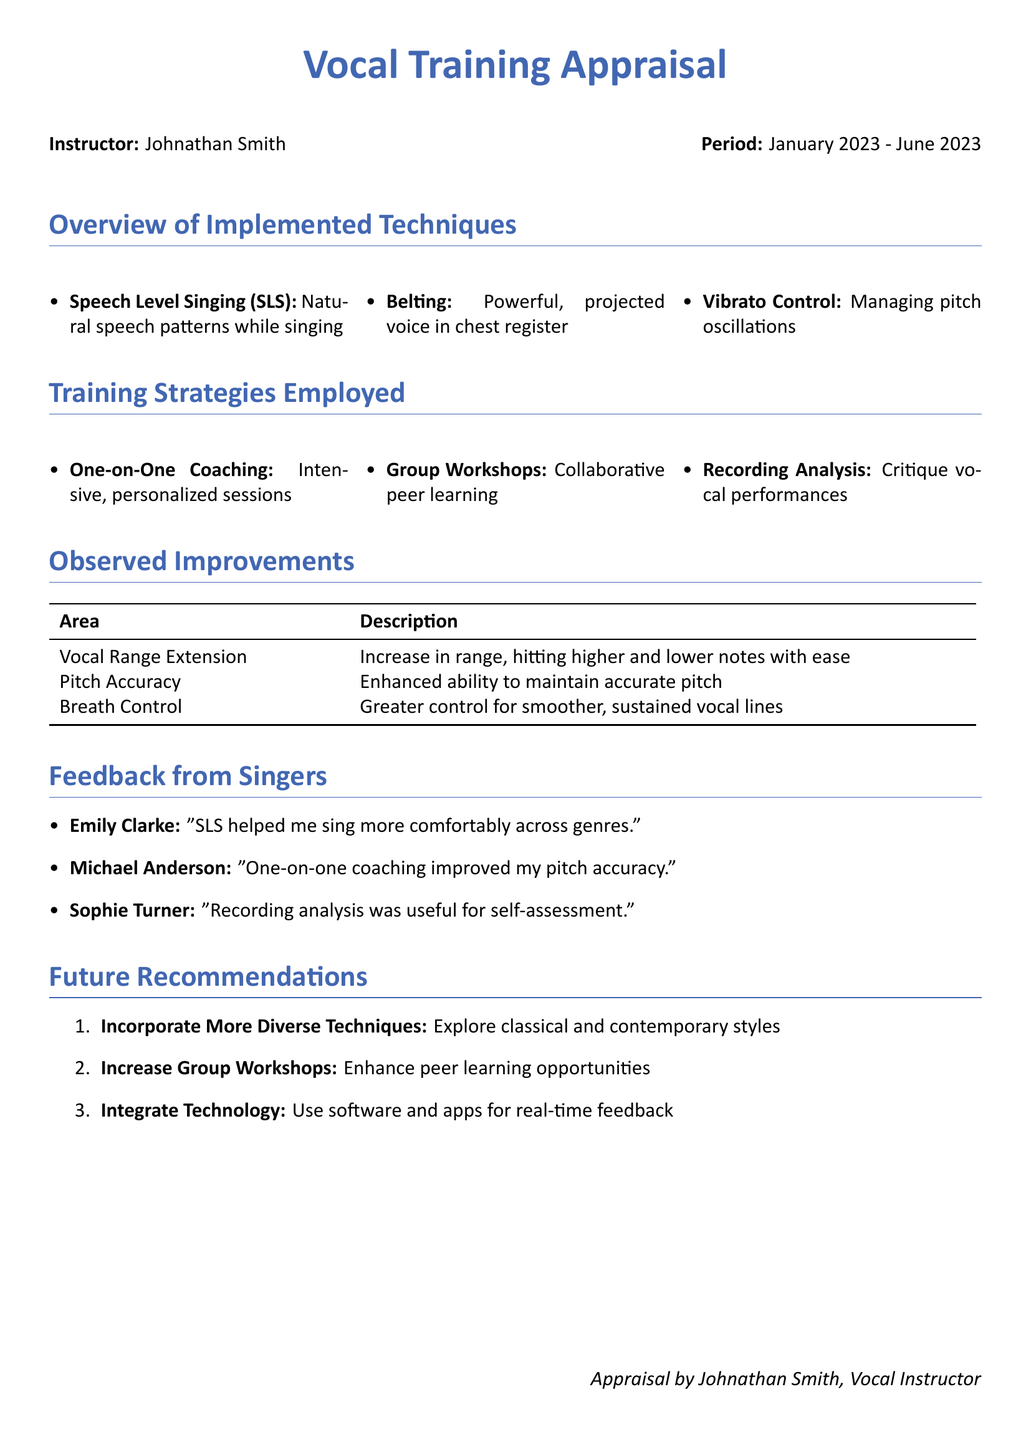What are the three vocal techniques implemented? The document lists three vocal techniques: Speech Level Singing, Belting, and Vibrato Control.
Answer: Speech Level Singing, Belting, Vibrato Control Who is the instructor mentioned in the document? The document specifies that the instructor is Johnathan Smith.
Answer: Johnathan Smith What was the period covered in this appraisal? The period mentioned in the document is from January 2023 to June 2023.
Answer: January 2023 - June 2023 What feedback did Emily Clarke provide? The document quotes Emily Clarke stating that SLS helped her sing more comfortably across genres.
Answer: "SLS helped me sing more comfortably across genres." What is one area of observed improvement? The document states that vocal range extension is one area of improvement, among others.
Answer: Vocal Range Extension What type of training strategy involved peer learning? The document indicates that Group Workshops involve collaborative peer learning.
Answer: Group Workshops What is one recommendation for future training? The document recommends incorporating more diverse techniques to explore classical and contemporary styles.
Answer: Incorporate More Diverse Techniques How did Michael Anderson feel about the coaching type? Michael Anderson felt that one-on-one coaching improved his pitch accuracy, as noted in the feedback section.
Answer: "One-on-one coaching improved my pitch accuracy." 